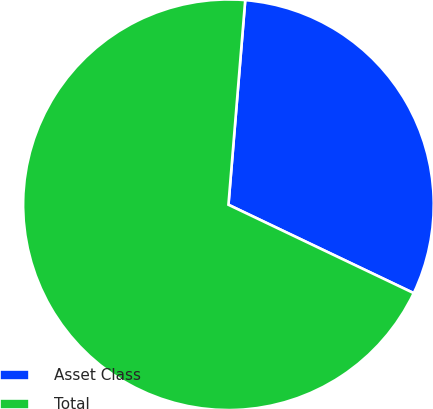<chart> <loc_0><loc_0><loc_500><loc_500><pie_chart><fcel>Asset Class<fcel>Total<nl><fcel>30.78%<fcel>69.22%<nl></chart> 